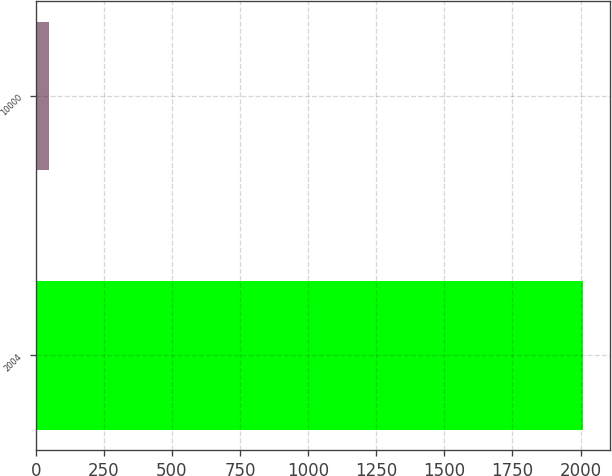<chart> <loc_0><loc_0><loc_500><loc_500><bar_chart><fcel>2004<fcel>10000<nl><fcel>2009<fcel>49.94<nl></chart> 